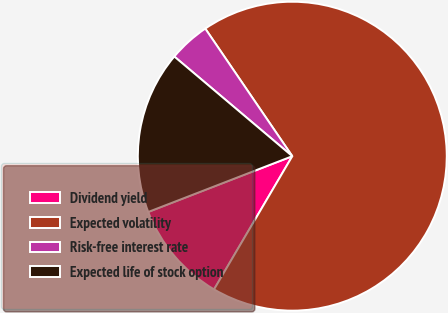Convert chart. <chart><loc_0><loc_0><loc_500><loc_500><pie_chart><fcel>Dividend yield<fcel>Expected volatility<fcel>Risk-free interest rate<fcel>Expected life of stock option<nl><fcel>10.67%<fcel>67.98%<fcel>4.31%<fcel>17.04%<nl></chart> 